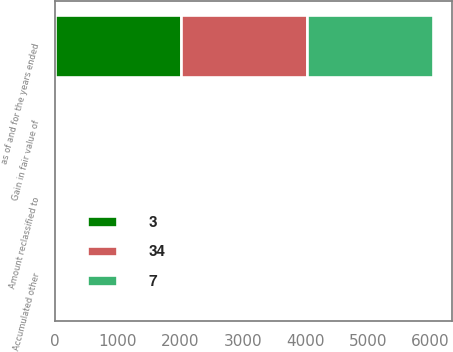Convert chart to OTSL. <chart><loc_0><loc_0><loc_500><loc_500><stacked_bar_chart><ecel><fcel>as of and for the years ended<fcel>Accumulated other<fcel>Gain in fair value of<fcel>Amount reclassified to<nl><fcel>3<fcel>2016<fcel>3<fcel>1<fcel>5<nl><fcel>7<fcel>2015<fcel>7<fcel>4<fcel>31<nl><fcel>34<fcel>2014<fcel>34<fcel>32<fcel>8<nl></chart> 